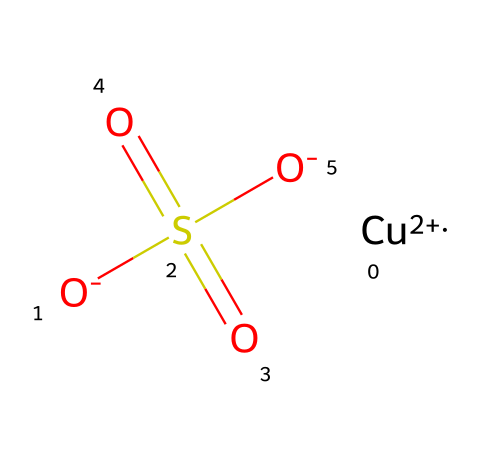What is the central metal ion in this compound? The chemical structure indicates the presence of a copper atom denoted as 'Cu' in the SMILES notation, which is the central metal ion in the compound.
Answer: copper How many sulfate groups are present in the molecule? The SMILES notation shows one instance of 'S(=O)(=O)', indicating that there is one sulfate group in the molecular structure.
Answer: one What is the oxidation state of copper in this compound? The notation '[Cu+2]' clearly shows that copper has a +2 oxidation state in this compound, indicating it has lost two electrons.
Answer: +2 What is the total number of oxygen atoms in the molecule? By examining the structure, there are four oxygen atoms. Two from the sulfate group (S(=O)(=O)) and two are indicated by the two '[O-]' notations.
Answer: four What type of agricultural application is this chemical primarily used for? As a fungicide, copper sulfate is primarily applied in agriculture to control fungal diseases in crops and is effective in water treatment to prevent algal blooms.
Answer: fungicide Does this compound contain any anions? The structure shows the presence of negatively charged sulfate groups '[O-]' and anions formed in the presence of copper ions, indicating that this compound contains anions.
Answer: yes 